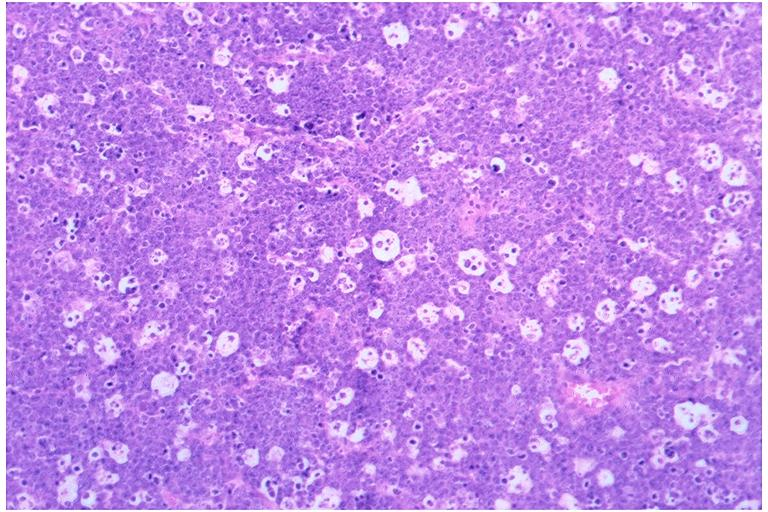s oral present?
Answer the question using a single word or phrase. Yes 